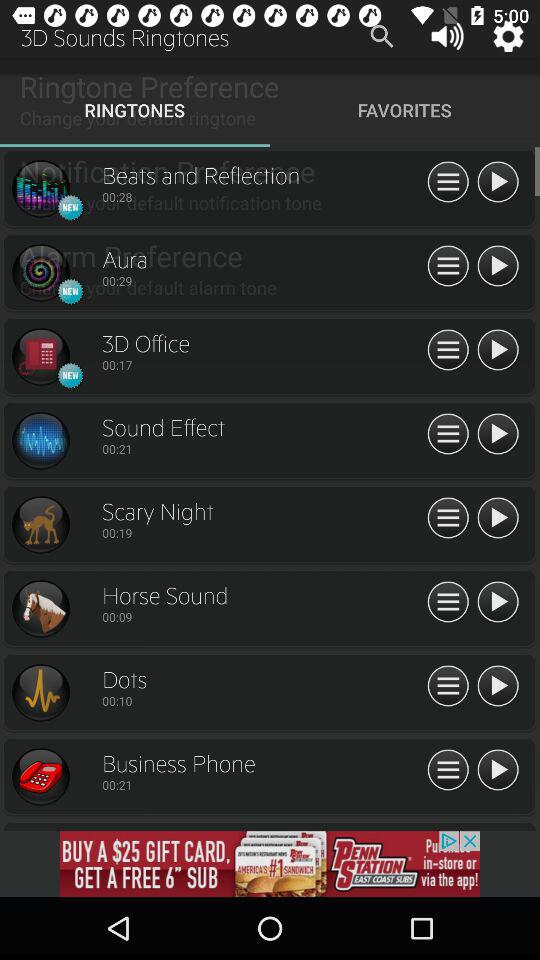What is the duration of the aura? The duration of the aura is 00:29. 